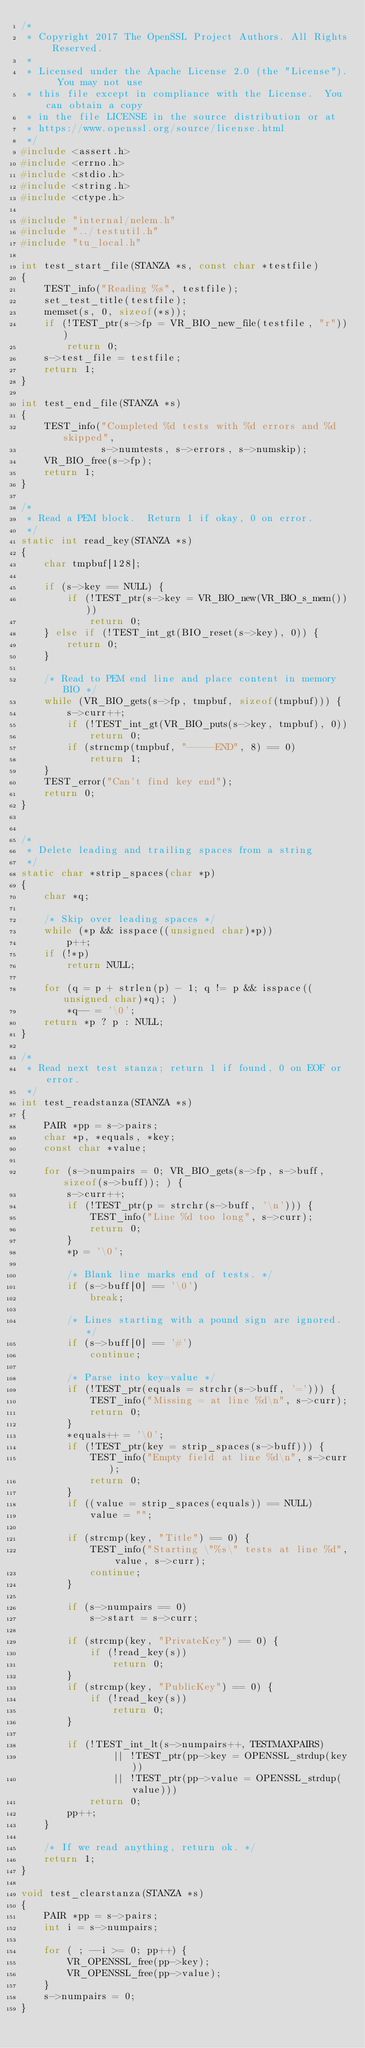Convert code to text. <code><loc_0><loc_0><loc_500><loc_500><_C_>/*
 * Copyright 2017 The OpenSSL Project Authors. All Rights Reserved.
 *
 * Licensed under the Apache License 2.0 (the "License").  You may not use
 * this file except in compliance with the License.  You can obtain a copy
 * in the file LICENSE in the source distribution or at
 * https://www.openssl.org/source/license.html
 */
#include <assert.h>
#include <errno.h>
#include <stdio.h>
#include <string.h>
#include <ctype.h>

#include "internal/nelem.h"
#include "../testutil.h"
#include "tu_local.h"

int test_start_file(STANZA *s, const char *testfile)
{
    TEST_info("Reading %s", testfile);
    set_test_title(testfile);
    memset(s, 0, sizeof(*s));
    if (!TEST_ptr(s->fp = VR_BIO_new_file(testfile, "r")))
        return 0;
    s->test_file = testfile;
    return 1;
}

int test_end_file(STANZA *s)
{
    TEST_info("Completed %d tests with %d errors and %d skipped",
              s->numtests, s->errors, s->numskip);
    VR_BIO_free(s->fp);
    return 1;
}

/*
 * Read a PEM block.  Return 1 if okay, 0 on error.
 */
static int read_key(STANZA *s)
{
    char tmpbuf[128];

    if (s->key == NULL) {
        if (!TEST_ptr(s->key = VR_BIO_new(VR_BIO_s_mem())))
            return 0;
    } else if (!TEST_int_gt(BIO_reset(s->key), 0)) {
        return 0;
    }

    /* Read to PEM end line and place content in memory BIO */
    while (VR_BIO_gets(s->fp, tmpbuf, sizeof(tmpbuf))) {
        s->curr++;
        if (!TEST_int_gt(VR_BIO_puts(s->key, tmpbuf), 0))
            return 0;
        if (strncmp(tmpbuf, "-----END", 8) == 0)
            return 1;
    }
    TEST_error("Can't find key end");
    return 0;
}


/*
 * Delete leading and trailing spaces from a string
 */
static char *strip_spaces(char *p)
{
    char *q;

    /* Skip over leading spaces */
    while (*p && isspace((unsigned char)*p))
        p++;
    if (!*p)
        return NULL;

    for (q = p + strlen(p) - 1; q != p && isspace((unsigned char)*q); )
        *q-- = '\0';
    return *p ? p : NULL;
}

/*
 * Read next test stanza; return 1 if found, 0 on EOF or error.
 */
int test_readstanza(STANZA *s)
{
    PAIR *pp = s->pairs;
    char *p, *equals, *key;
    const char *value;

    for (s->numpairs = 0; VR_BIO_gets(s->fp, s->buff, sizeof(s->buff)); ) {
        s->curr++;
        if (!TEST_ptr(p = strchr(s->buff, '\n'))) {
            TEST_info("Line %d too long", s->curr);
            return 0;
        }
        *p = '\0';

        /* Blank line marks end of tests. */
        if (s->buff[0] == '\0')
            break;

        /* Lines starting with a pound sign are ignored. */
        if (s->buff[0] == '#')
            continue;

        /* Parse into key=value */
        if (!TEST_ptr(equals = strchr(s->buff, '='))) {
            TEST_info("Missing = at line %d\n", s->curr);
            return 0;
        }
        *equals++ = '\0';
        if (!TEST_ptr(key = strip_spaces(s->buff))) {
            TEST_info("Empty field at line %d\n", s->curr);
            return 0;
        }
        if ((value = strip_spaces(equals)) == NULL)
            value = "";

        if (strcmp(key, "Title") == 0) {
            TEST_info("Starting \"%s\" tests at line %d", value, s->curr);
            continue;
        }

        if (s->numpairs == 0)
            s->start = s->curr;

        if (strcmp(key, "PrivateKey") == 0) {
            if (!read_key(s))
                return 0;
        }
        if (strcmp(key, "PublicKey") == 0) {
            if (!read_key(s))
                return 0;
        }

        if (!TEST_int_lt(s->numpairs++, TESTMAXPAIRS)
                || !TEST_ptr(pp->key = OPENSSL_strdup(key))
                || !TEST_ptr(pp->value = OPENSSL_strdup(value)))
            return 0;
        pp++;
    }

    /* If we read anything, return ok. */
    return 1;
}

void test_clearstanza(STANZA *s)
{
    PAIR *pp = s->pairs;
    int i = s->numpairs;

    for ( ; --i >= 0; pp++) {
        VR_OPENSSL_free(pp->key);
        VR_OPENSSL_free(pp->value);
    }
    s->numpairs = 0;
}
</code> 